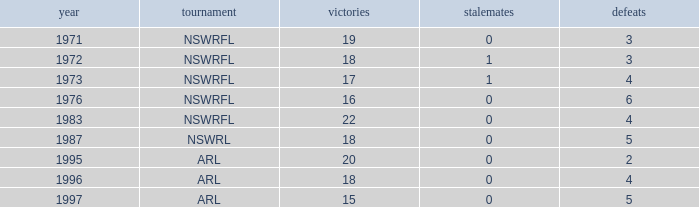What average Loses has Draws less than 0? None. 